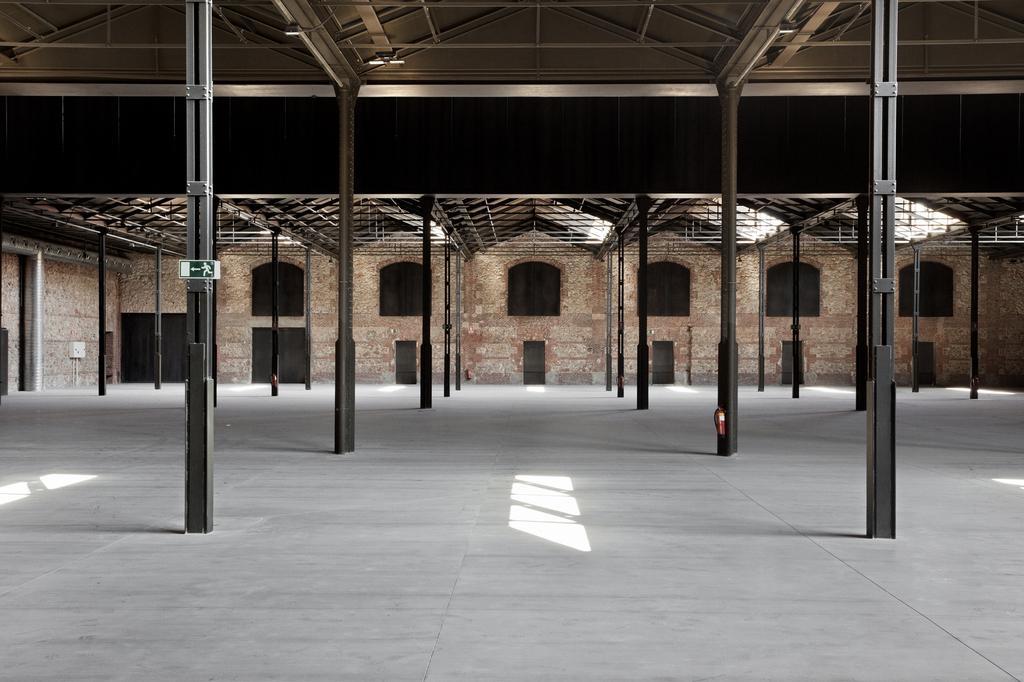Please provide a concise description of this image. In this image we can see a building, in front of the building, we can see the sheds, there are some poles and windows, also we can see a sign board on the pole. 